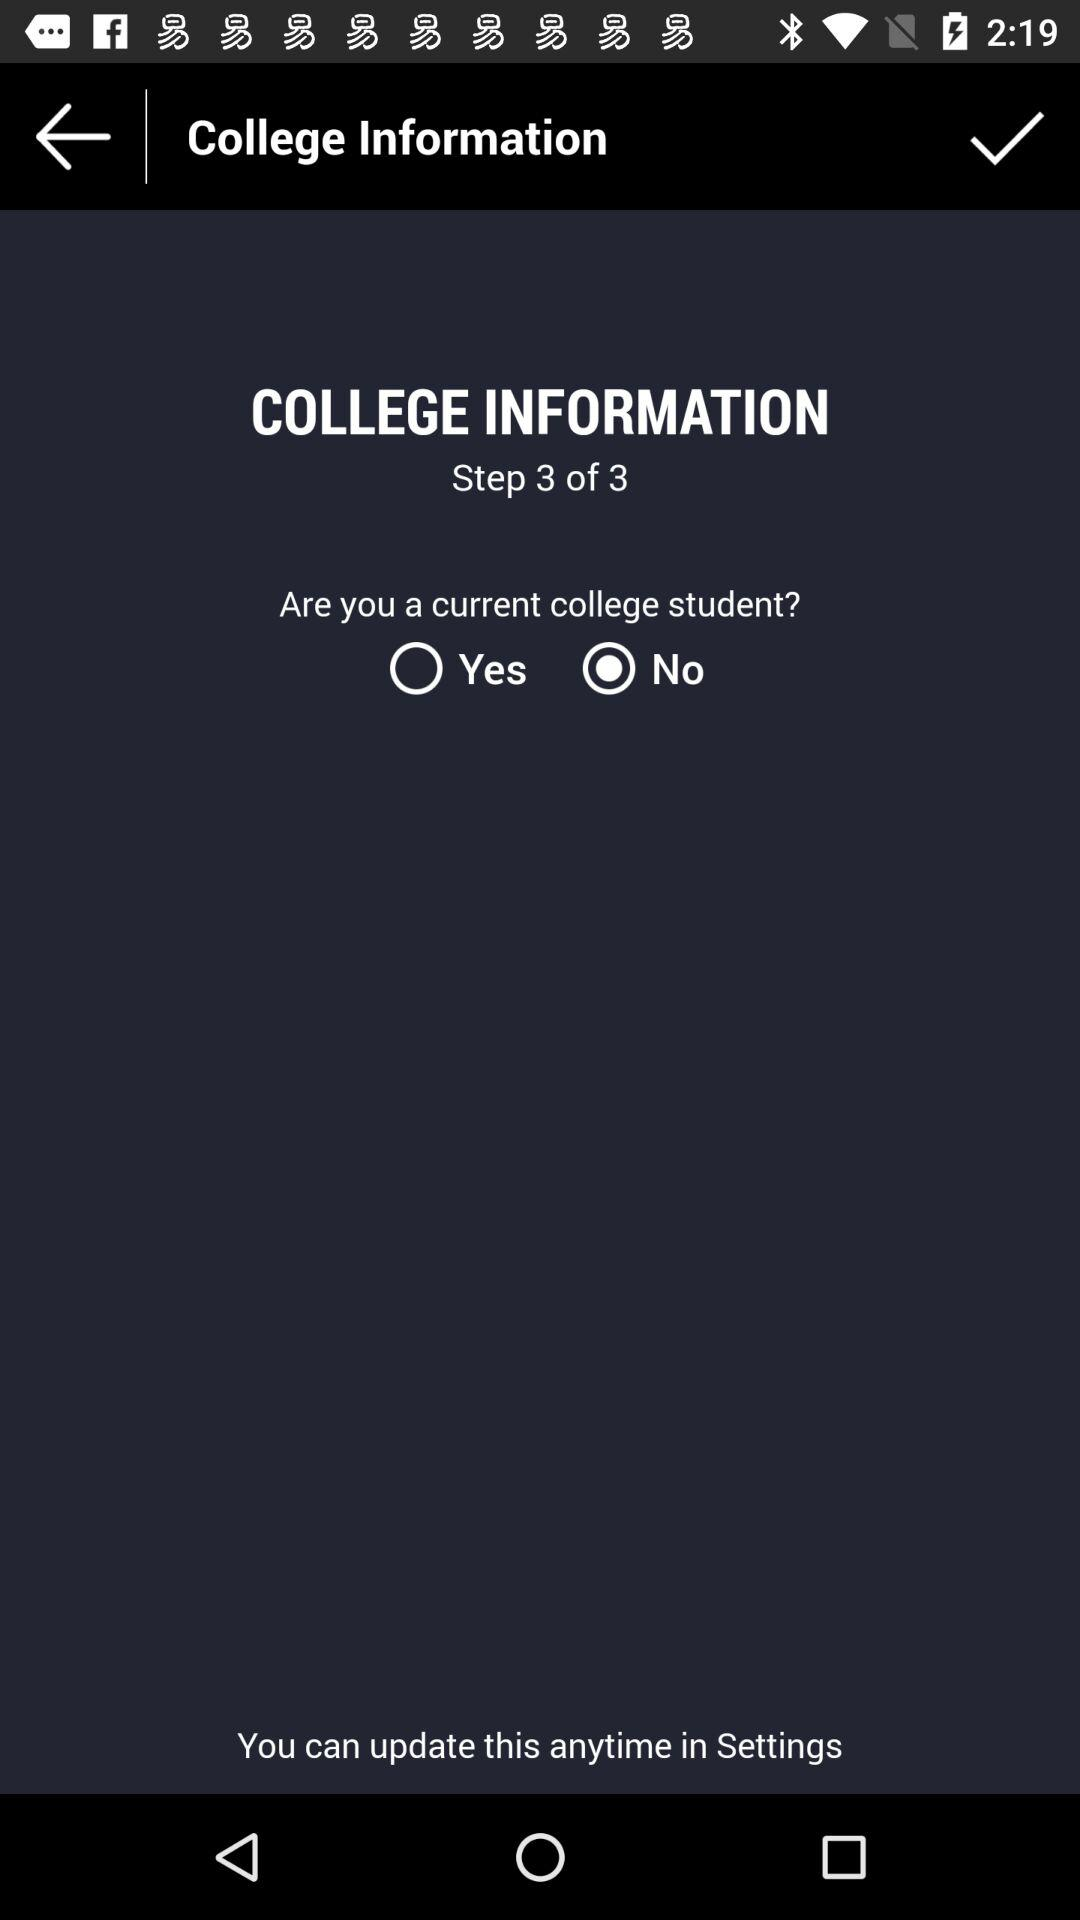Which radio button is selected? The selected radio button is "No". 